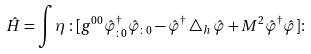Convert formula to latex. <formula><loc_0><loc_0><loc_500><loc_500>\hat { H } = \int \eta \, \colon [ g ^ { 0 0 } \hat { \varphi } _ { \colon 0 } ^ { \dagger } \hat { \varphi } _ { \colon 0 } - \hat { \varphi } ^ { \dagger } \bigtriangleup _ { h } \hat { \varphi } + M ^ { 2 } \hat { \varphi } ^ { \dagger } \hat { \varphi } ] \colon</formula> 